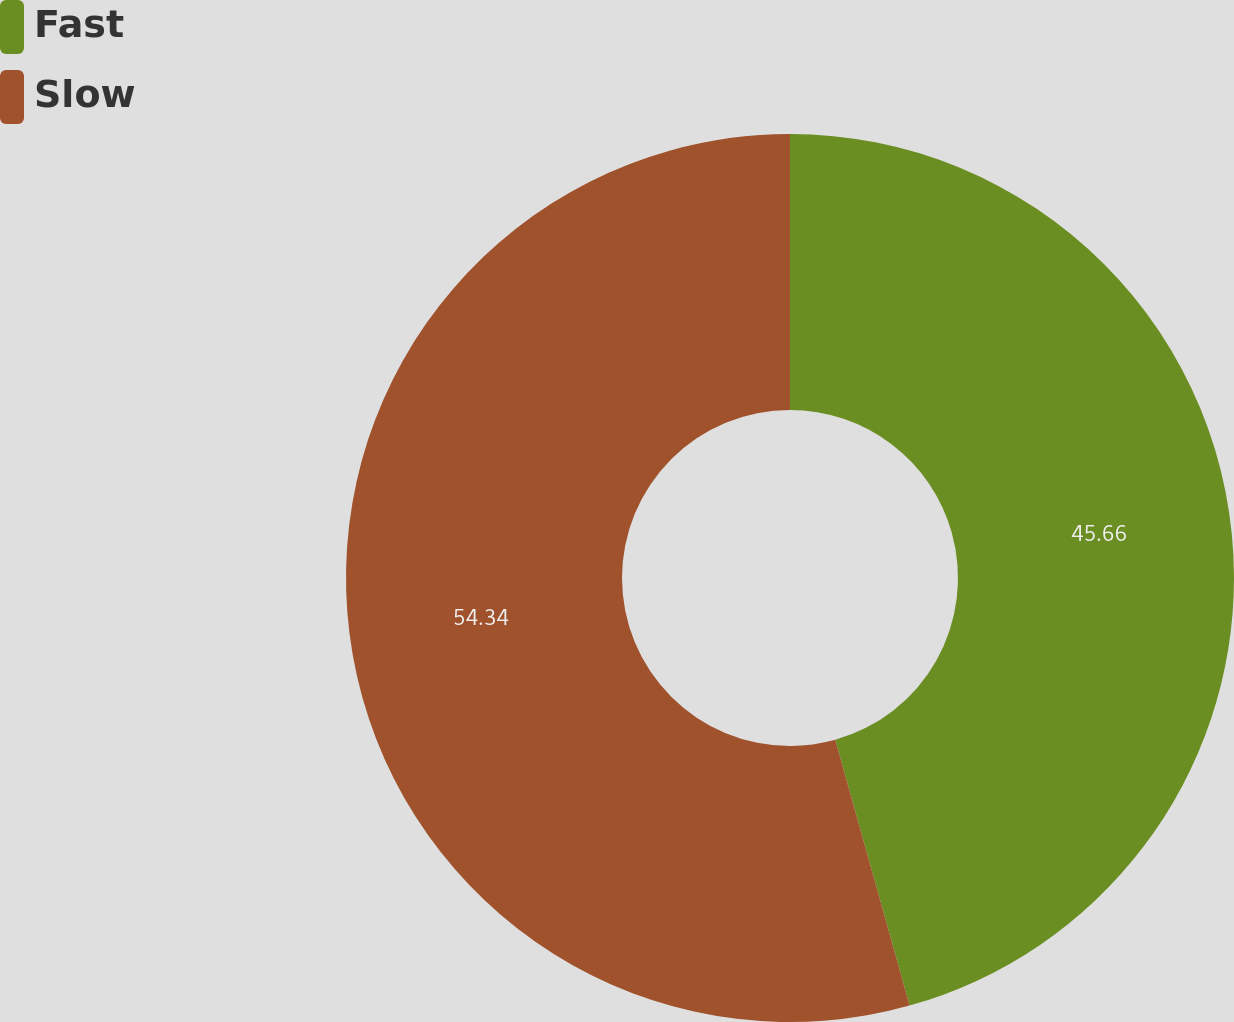Convert chart to OTSL. <chart><loc_0><loc_0><loc_500><loc_500><pie_chart><fcel>Fast<fcel>Slow<nl><fcel>45.66%<fcel>54.34%<nl></chart> 